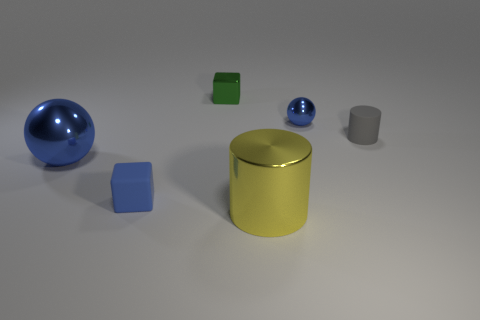Can you tell the approximate size relation between these objects? It appears that the large blue sphere is the biggest object. The yellow cylinder is shorter but wider than the green cube. The small blue sphere is noticeably smaller than its larger counterpart, and the blue and silver-gray cylinders are the smallest objects in terms of volume. 